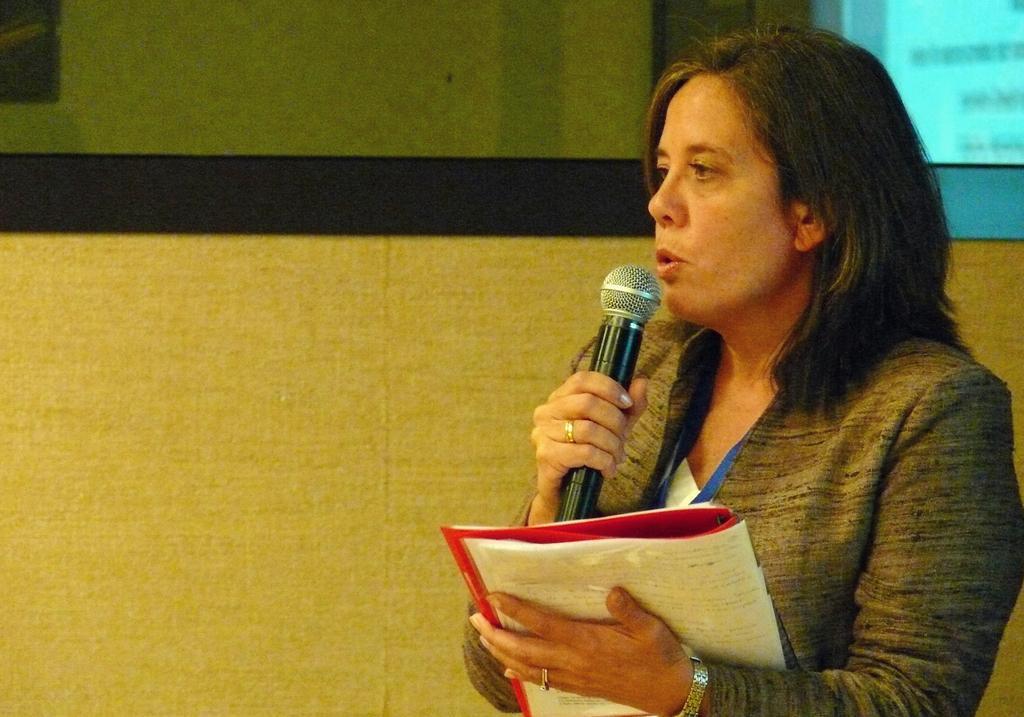In one or two sentences, can you explain what this image depicts? In this image there is a woman holding a mic in her right hand and holding a book in her left hand is delivering a speech, behind the women there is a screen. 